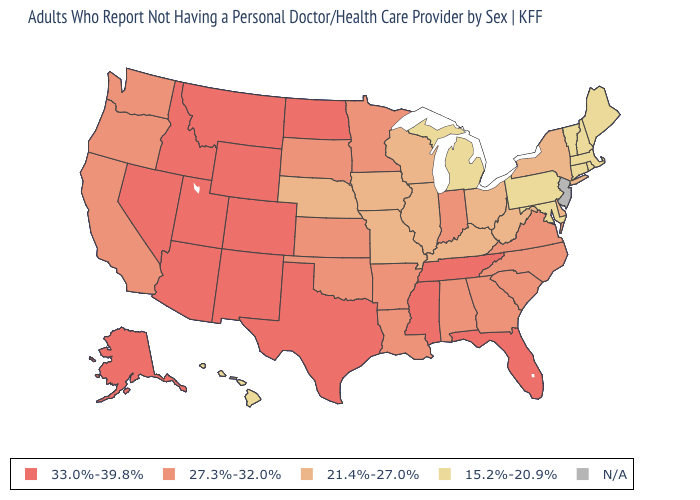What is the highest value in the USA?
Write a very short answer. 33.0%-39.8%. Among the states that border Ohio , does Indiana have the highest value?
Be succinct. Yes. How many symbols are there in the legend?
Give a very brief answer. 5. Name the states that have a value in the range 15.2%-20.9%?
Keep it brief. Connecticut, Hawaii, Maine, Maryland, Massachusetts, Michigan, New Hampshire, Pennsylvania, Rhode Island, Vermont. Does the map have missing data?
Write a very short answer. Yes. What is the value of Louisiana?
Short answer required. 27.3%-32.0%. Name the states that have a value in the range 21.4%-27.0%?
Give a very brief answer. Delaware, Illinois, Iowa, Kentucky, Missouri, Nebraska, New York, Ohio, West Virginia, Wisconsin. What is the lowest value in states that border Wyoming?
Quick response, please. 21.4%-27.0%. Name the states that have a value in the range 33.0%-39.8%?
Write a very short answer. Alaska, Arizona, Colorado, Florida, Idaho, Mississippi, Montana, Nevada, New Mexico, North Dakota, Tennessee, Texas, Utah, Wyoming. Which states have the highest value in the USA?
Short answer required. Alaska, Arizona, Colorado, Florida, Idaho, Mississippi, Montana, Nevada, New Mexico, North Dakota, Tennessee, Texas, Utah, Wyoming. What is the highest value in states that border Illinois?
Be succinct. 27.3%-32.0%. Does Idaho have the lowest value in the West?
Answer briefly. No. Among the states that border Mississippi , which have the lowest value?
Give a very brief answer. Alabama, Arkansas, Louisiana. 